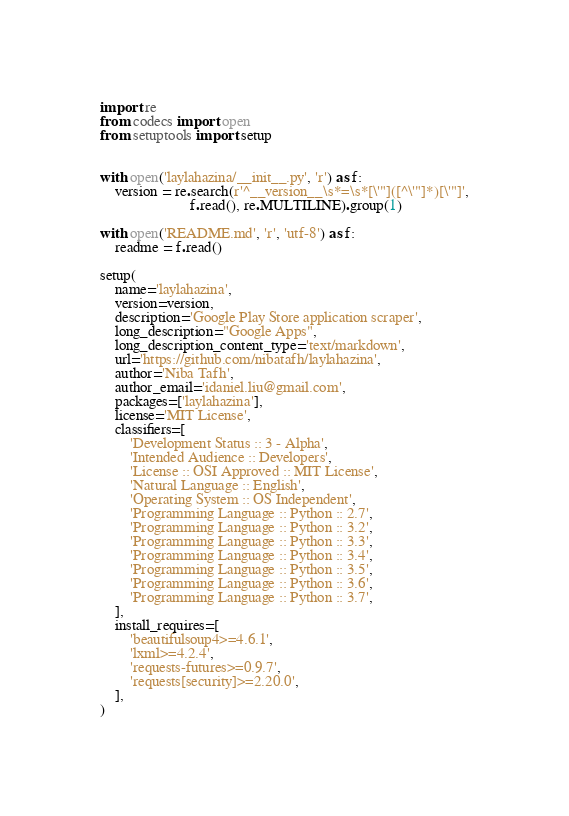<code> <loc_0><loc_0><loc_500><loc_500><_Python_>import re
from codecs import open
from setuptools import setup


with open('laylahazina/__init__.py', 'r') as f:
    version = re.search(r'^__version__\s*=\s*[\'"]([^\'"]*)[\'"]',
                        f.read(), re.MULTILINE).group(1)

with open('README.md', 'r', 'utf-8') as f:
    readme = f.read()

setup(
    name='laylahazina',
    version=version,
    description='Google Play Store application scraper',
    long_description="Google Apps",
    long_description_content_type='text/markdown',
    url='https://github.com/nibatafh/laylahazina',
    author='Niba Tafh',
    author_email='idaniel.liu@gmail.com',
    packages=['laylahazina'],
    license='MIT License',
    classifiers=[
        'Development Status :: 3 - Alpha',
        'Intended Audience :: Developers',
        'License :: OSI Approved :: MIT License',
        'Natural Language :: English',
        'Operating System :: OS Independent',
        'Programming Language :: Python :: 2.7',
        'Programming Language :: Python :: 3.2',
        'Programming Language :: Python :: 3.3',
        'Programming Language :: Python :: 3.4',
        'Programming Language :: Python :: 3.5',
        'Programming Language :: Python :: 3.6',
        'Programming Language :: Python :: 3.7',
    ],
    install_requires=[
        'beautifulsoup4>=4.6.1',
        'lxml>=4.2.4',
        'requests-futures>=0.9.7',
        'requests[security]>=2.20.0',
    ],
)
</code> 